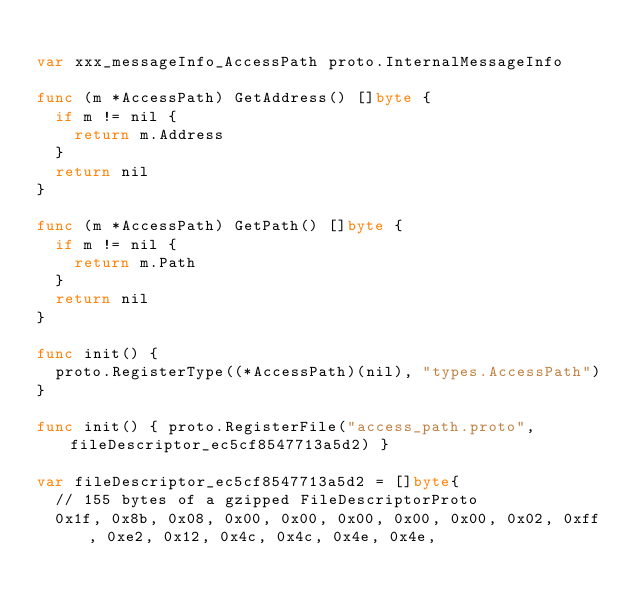Convert code to text. <code><loc_0><loc_0><loc_500><loc_500><_Go_>
var xxx_messageInfo_AccessPath proto.InternalMessageInfo

func (m *AccessPath) GetAddress() []byte {
	if m != nil {
		return m.Address
	}
	return nil
}

func (m *AccessPath) GetPath() []byte {
	if m != nil {
		return m.Path
	}
	return nil
}

func init() {
	proto.RegisterType((*AccessPath)(nil), "types.AccessPath")
}

func init() { proto.RegisterFile("access_path.proto", fileDescriptor_ec5cf8547713a5d2) }

var fileDescriptor_ec5cf8547713a5d2 = []byte{
	// 155 bytes of a gzipped FileDescriptorProto
	0x1f, 0x8b, 0x08, 0x00, 0x00, 0x00, 0x00, 0x00, 0x02, 0xff, 0xe2, 0x12, 0x4c, 0x4c, 0x4e, 0x4e,</code> 